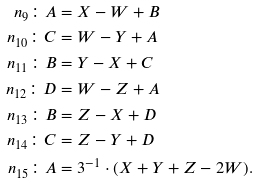Convert formula to latex. <formula><loc_0><loc_0><loc_500><loc_500>n _ { 9 } \colon A & = X - W + B \\ n _ { 1 0 } \colon C & = W - Y + A \\ n _ { 1 1 } \colon B & = Y - X + C \\ n _ { 1 2 } \colon D & = W - Z + A \\ n _ { 1 3 } \colon B & = Z - X + D \\ n _ { 1 4 } \colon C & = Z - Y + D \\ n _ { 1 5 } \colon A & = 3 ^ { - 1 } \cdot ( X + Y + Z - 2 W ) .</formula> 